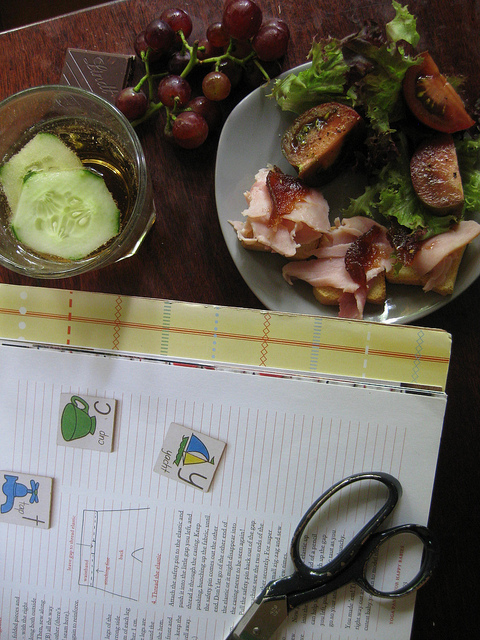Identify the text displayed in this image. c cup y yocht tap 